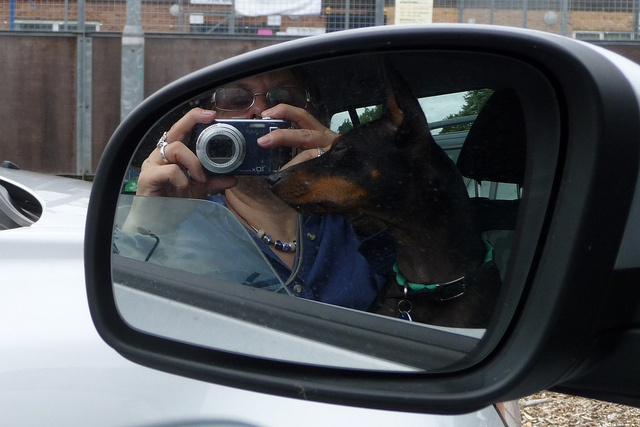Describe the objects in this image and their specific colors. I can see car in brown, lightgray, darkgray, black, and gray tones, dog in brown, black, maroon, teal, and gray tones, and people in brown, black, gray, and navy tones in this image. 